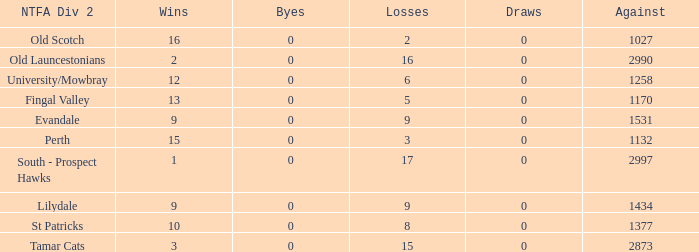What is the lowest number of draws of the team with 9 wins and less than 0 byes? None. 